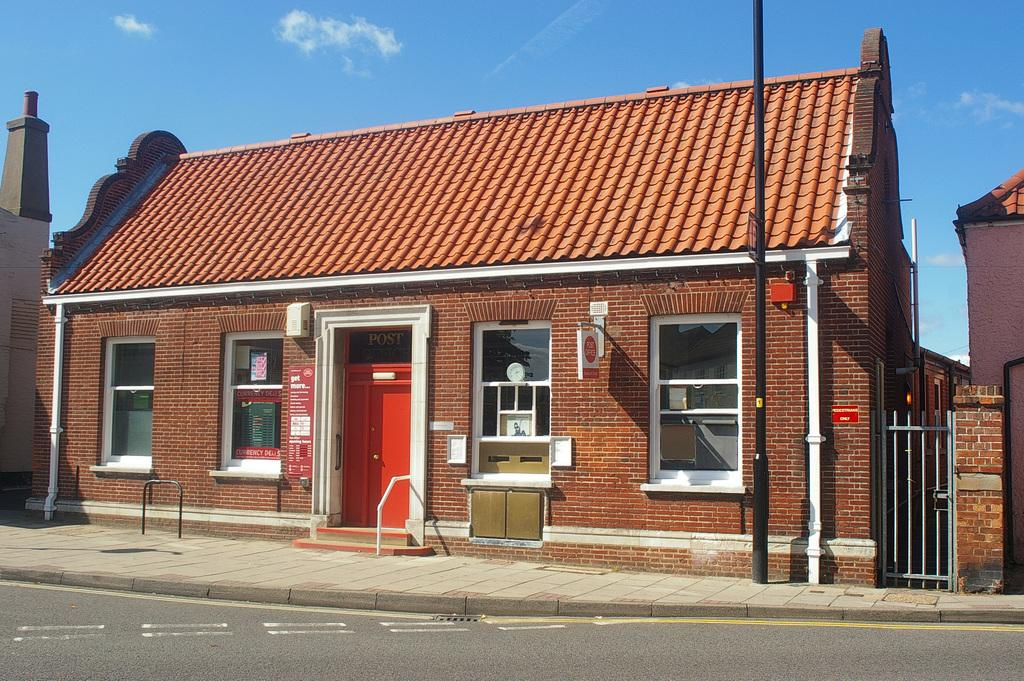What type of structures can be seen in the image? There are sheds in the image. What is the purpose of the gate in the image? The gate in the image might be used for controlling access or as a boundary. What is the pole in the image used for? The pole in the image might be used for supporting a fence, sign, or other object. What are the rods in the image used for? The rods in the image might be used for supporting or reinforcing structures. What is visible at the top of the image? The sky is visible at the top of the image. What is visible at the bottom of the image? There is a road at the bottom of the image. What type of rice is being cooked in the image? There is no rice present in the image; it features sheds, a gate, a pole, rods, the sky, and a road. What type of polish is being applied to the linen in the image? There is no linen or polish present in the image. 